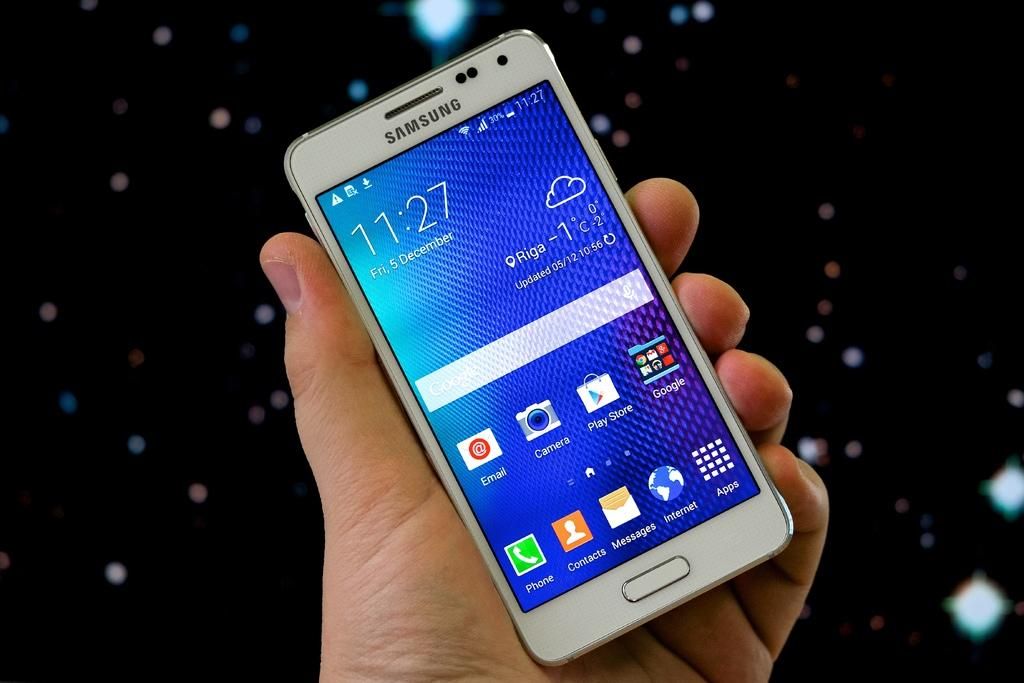<image>
Share a concise interpretation of the image provided. a Samsung cell phone with the time reading 11:27 